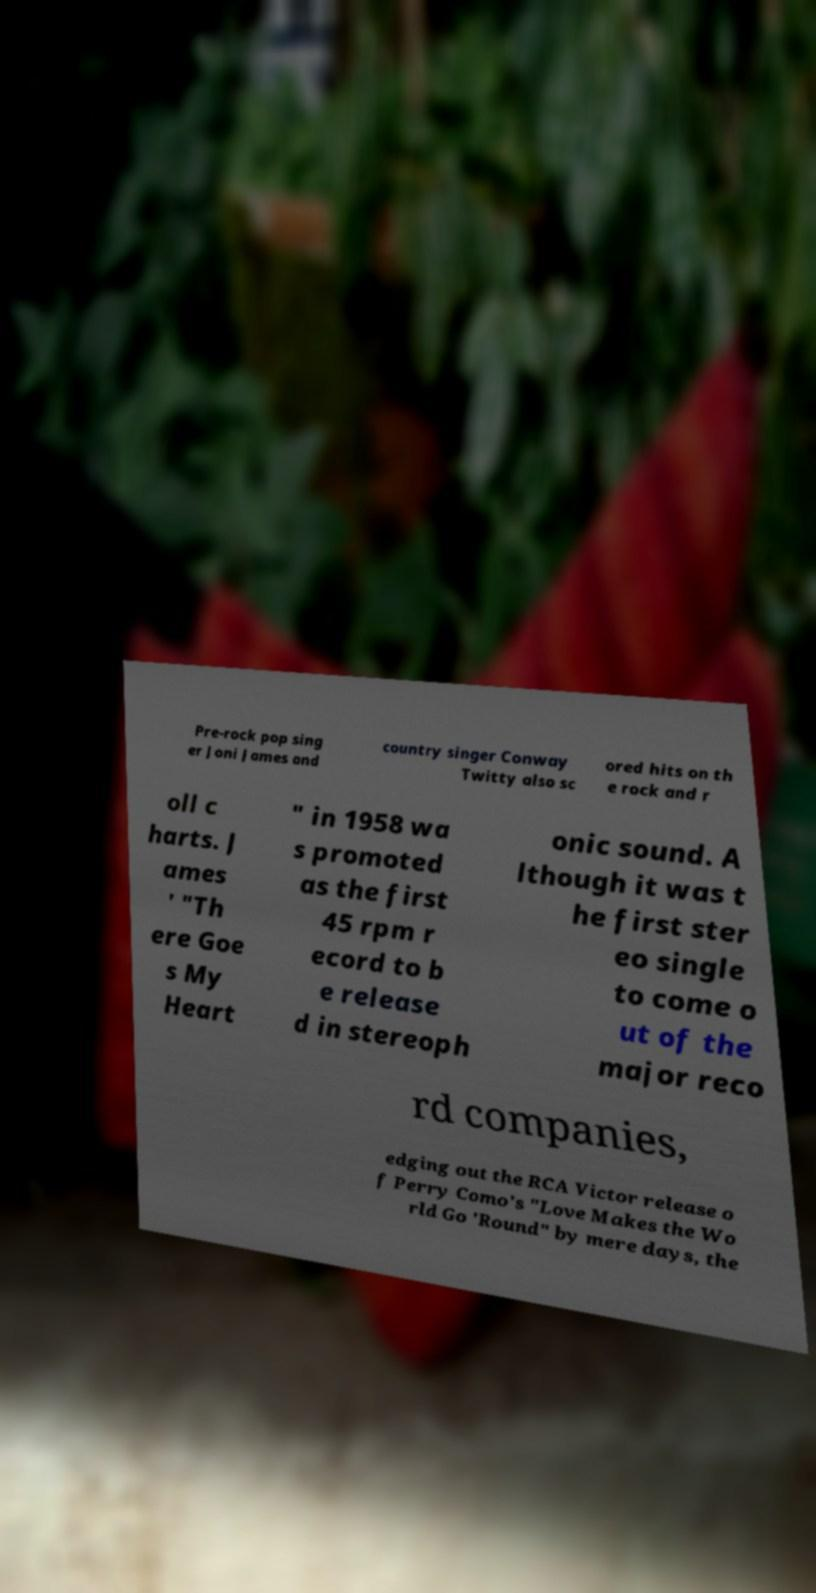Please read and relay the text visible in this image. What does it say? Pre-rock pop sing er Joni James and country singer Conway Twitty also sc ored hits on th e rock and r oll c harts. J ames ' "Th ere Goe s My Heart " in 1958 wa s promoted as the first 45 rpm r ecord to b e release d in stereoph onic sound. A lthough it was t he first ster eo single to come o ut of the major reco rd companies, edging out the RCA Victor release o f Perry Como's "Love Makes the Wo rld Go 'Round" by mere days, the 